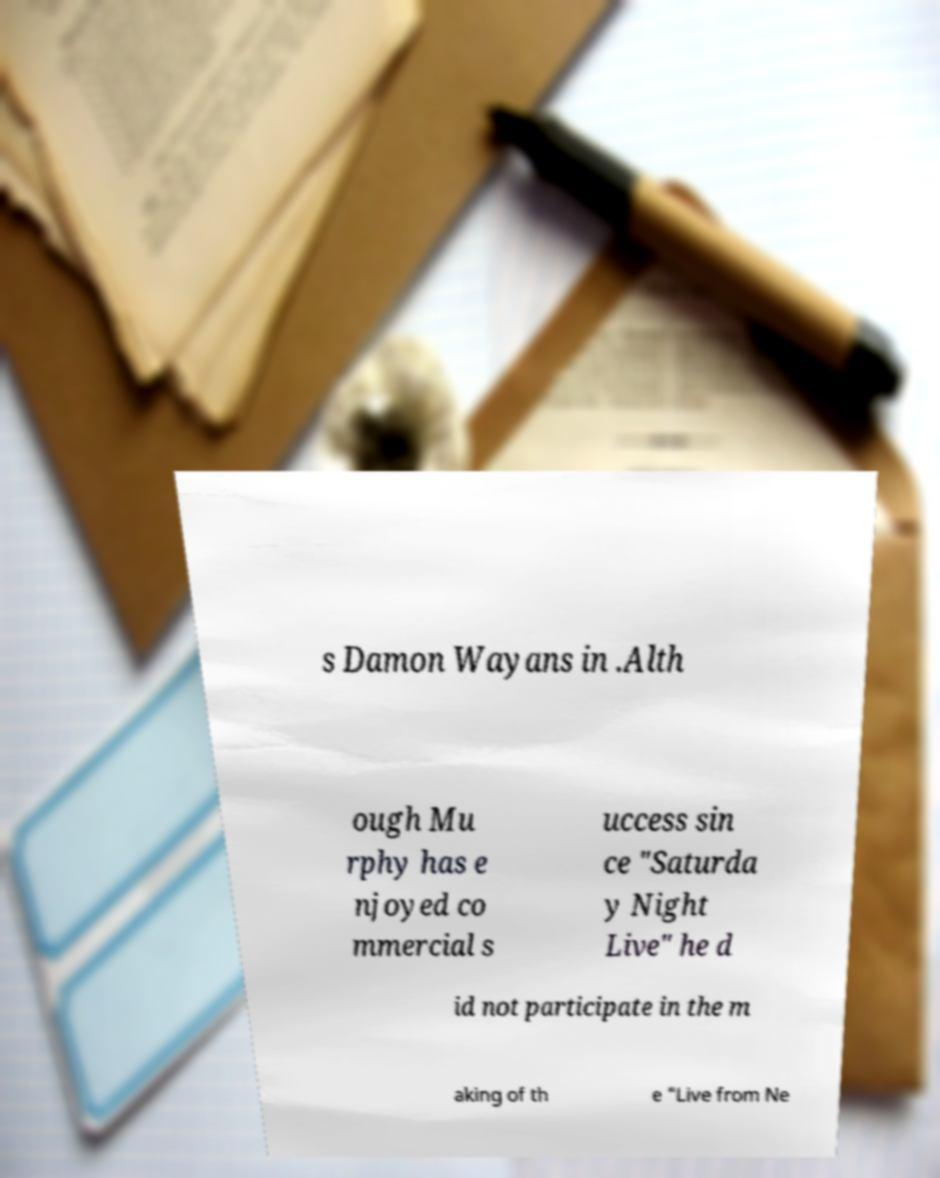Can you accurately transcribe the text from the provided image for me? s Damon Wayans in .Alth ough Mu rphy has e njoyed co mmercial s uccess sin ce "Saturda y Night Live" he d id not participate in the m aking of th e "Live from Ne 